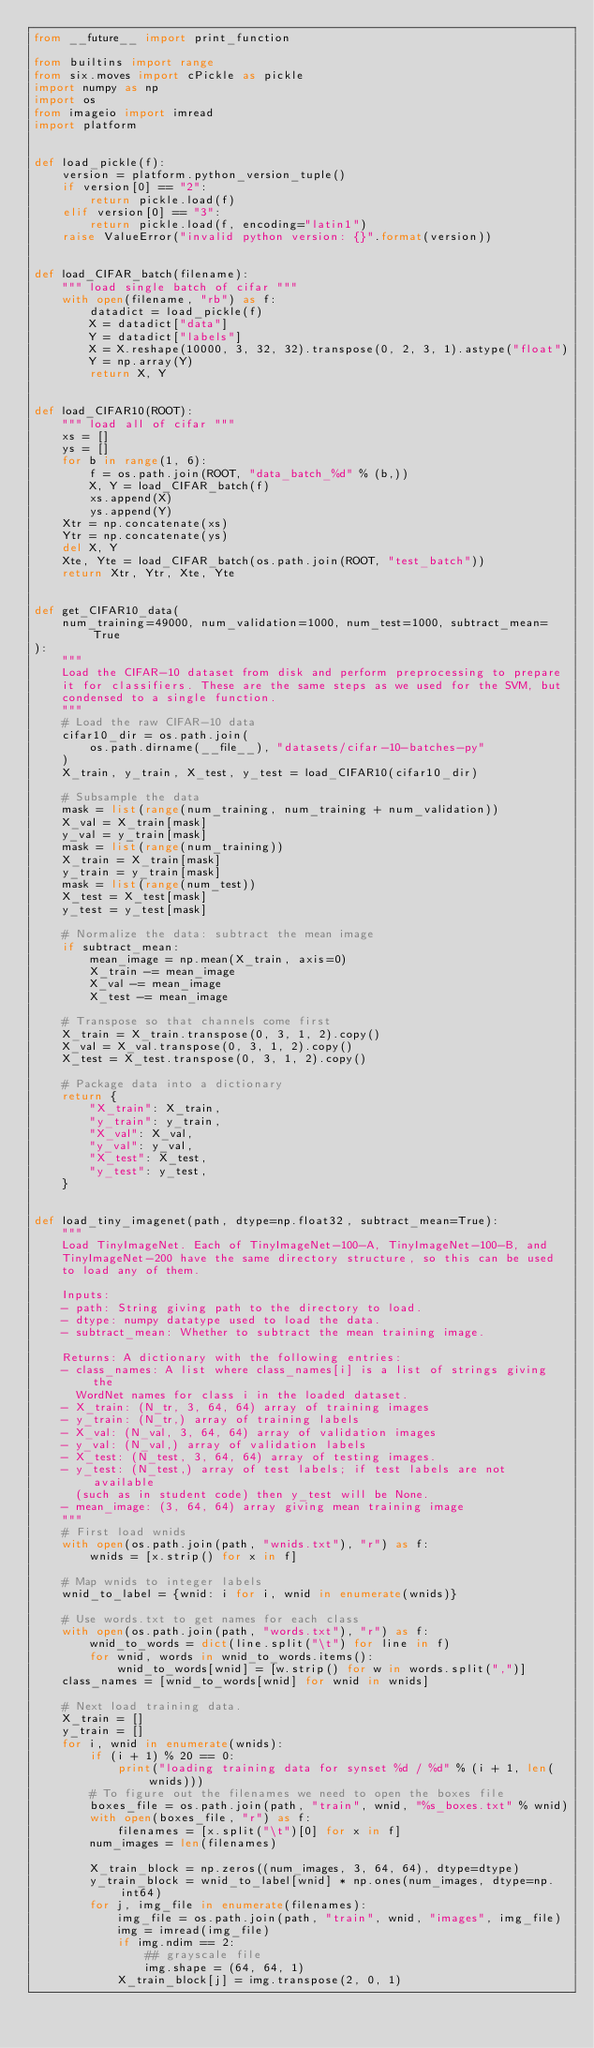<code> <loc_0><loc_0><loc_500><loc_500><_Python_>from __future__ import print_function

from builtins import range
from six.moves import cPickle as pickle
import numpy as np
import os
from imageio import imread
import platform


def load_pickle(f):
    version = platform.python_version_tuple()
    if version[0] == "2":
        return pickle.load(f)
    elif version[0] == "3":
        return pickle.load(f, encoding="latin1")
    raise ValueError("invalid python version: {}".format(version))


def load_CIFAR_batch(filename):
    """ load single batch of cifar """
    with open(filename, "rb") as f:
        datadict = load_pickle(f)
        X = datadict["data"]
        Y = datadict["labels"]
        X = X.reshape(10000, 3, 32, 32).transpose(0, 2, 3, 1).astype("float")
        Y = np.array(Y)
        return X, Y


def load_CIFAR10(ROOT):
    """ load all of cifar """
    xs = []
    ys = []
    for b in range(1, 6):
        f = os.path.join(ROOT, "data_batch_%d" % (b,))
        X, Y = load_CIFAR_batch(f)
        xs.append(X)
        ys.append(Y)
    Xtr = np.concatenate(xs)
    Ytr = np.concatenate(ys)
    del X, Y
    Xte, Yte = load_CIFAR_batch(os.path.join(ROOT, "test_batch"))
    return Xtr, Ytr, Xte, Yte


def get_CIFAR10_data(
    num_training=49000, num_validation=1000, num_test=1000, subtract_mean=True
):
    """
    Load the CIFAR-10 dataset from disk and perform preprocessing to prepare
    it for classifiers. These are the same steps as we used for the SVM, but
    condensed to a single function.
    """
    # Load the raw CIFAR-10 data
    cifar10_dir = os.path.join(
        os.path.dirname(__file__), "datasets/cifar-10-batches-py"
    )
    X_train, y_train, X_test, y_test = load_CIFAR10(cifar10_dir)

    # Subsample the data
    mask = list(range(num_training, num_training + num_validation))
    X_val = X_train[mask]
    y_val = y_train[mask]
    mask = list(range(num_training))
    X_train = X_train[mask]
    y_train = y_train[mask]
    mask = list(range(num_test))
    X_test = X_test[mask]
    y_test = y_test[mask]

    # Normalize the data: subtract the mean image
    if subtract_mean:
        mean_image = np.mean(X_train, axis=0)
        X_train -= mean_image
        X_val -= mean_image
        X_test -= mean_image

    # Transpose so that channels come first
    X_train = X_train.transpose(0, 3, 1, 2).copy()
    X_val = X_val.transpose(0, 3, 1, 2).copy()
    X_test = X_test.transpose(0, 3, 1, 2).copy()

    # Package data into a dictionary
    return {
        "X_train": X_train,
        "y_train": y_train,
        "X_val": X_val,
        "y_val": y_val,
        "X_test": X_test,
        "y_test": y_test,
    }


def load_tiny_imagenet(path, dtype=np.float32, subtract_mean=True):
    """
    Load TinyImageNet. Each of TinyImageNet-100-A, TinyImageNet-100-B, and
    TinyImageNet-200 have the same directory structure, so this can be used
    to load any of them.

    Inputs:
    - path: String giving path to the directory to load.
    - dtype: numpy datatype used to load the data.
    - subtract_mean: Whether to subtract the mean training image.

    Returns: A dictionary with the following entries:
    - class_names: A list where class_names[i] is a list of strings giving the
      WordNet names for class i in the loaded dataset.
    - X_train: (N_tr, 3, 64, 64) array of training images
    - y_train: (N_tr,) array of training labels
    - X_val: (N_val, 3, 64, 64) array of validation images
    - y_val: (N_val,) array of validation labels
    - X_test: (N_test, 3, 64, 64) array of testing images.
    - y_test: (N_test,) array of test labels; if test labels are not available
      (such as in student code) then y_test will be None.
    - mean_image: (3, 64, 64) array giving mean training image
    """
    # First load wnids
    with open(os.path.join(path, "wnids.txt"), "r") as f:
        wnids = [x.strip() for x in f]

    # Map wnids to integer labels
    wnid_to_label = {wnid: i for i, wnid in enumerate(wnids)}

    # Use words.txt to get names for each class
    with open(os.path.join(path, "words.txt"), "r") as f:
        wnid_to_words = dict(line.split("\t") for line in f)
        for wnid, words in wnid_to_words.items():
            wnid_to_words[wnid] = [w.strip() for w in words.split(",")]
    class_names = [wnid_to_words[wnid] for wnid in wnids]

    # Next load training data.
    X_train = []
    y_train = []
    for i, wnid in enumerate(wnids):
        if (i + 1) % 20 == 0:
            print("loading training data for synset %d / %d" % (i + 1, len(wnids)))
        # To figure out the filenames we need to open the boxes file
        boxes_file = os.path.join(path, "train", wnid, "%s_boxes.txt" % wnid)
        with open(boxes_file, "r") as f:
            filenames = [x.split("\t")[0] for x in f]
        num_images = len(filenames)

        X_train_block = np.zeros((num_images, 3, 64, 64), dtype=dtype)
        y_train_block = wnid_to_label[wnid] * np.ones(num_images, dtype=np.int64)
        for j, img_file in enumerate(filenames):
            img_file = os.path.join(path, "train", wnid, "images", img_file)
            img = imread(img_file)
            if img.ndim == 2:
                ## grayscale file
                img.shape = (64, 64, 1)
            X_train_block[j] = img.transpose(2, 0, 1)</code> 